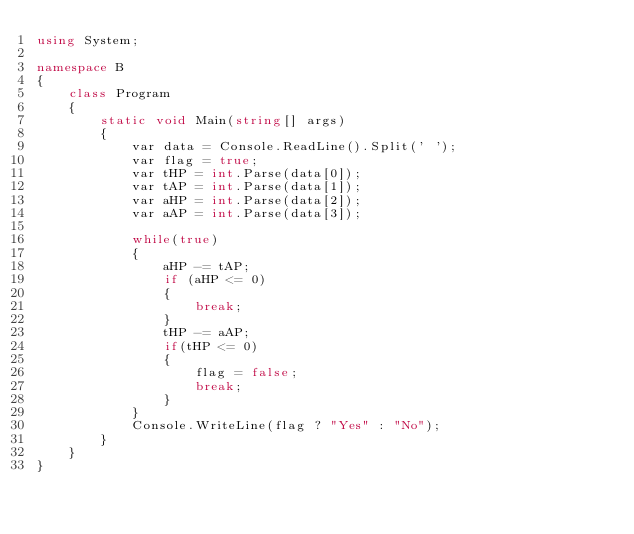Convert code to text. <code><loc_0><loc_0><loc_500><loc_500><_C#_>using System;

namespace B
{
    class Program
    {
        static void Main(string[] args)
        {
            var data = Console.ReadLine().Split(' ');
            var flag = true;
            var tHP = int.Parse(data[0]);
            var tAP = int.Parse(data[1]);
            var aHP = int.Parse(data[2]);
            var aAP = int.Parse(data[3]);

            while(true)
            {
                aHP -= tAP;
                if (aHP <= 0)
                {
                    break;
                }
                tHP -= aAP;
                if(tHP <= 0)
                {
                    flag = false;
                    break;
                }
            }
            Console.WriteLine(flag ? "Yes" : "No");
        }
    }
}
</code> 